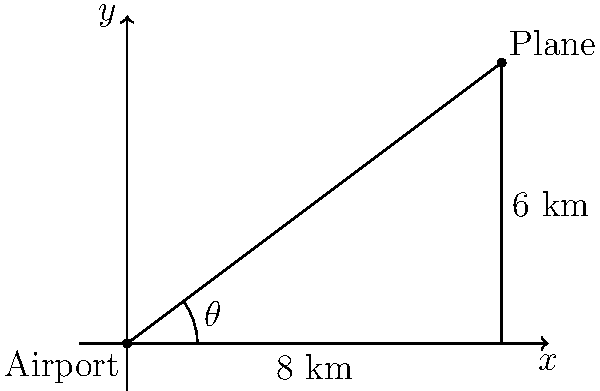An airport's radar system detects a plane at a distance of 10 km and an angle of elevation of 36.87°. What is the plane's altitude and its horizontal distance from the airport? How can this information be used to optimize flight paths and reduce fuel consumption? Let's approach this step-by-step:

1) We can use trigonometric functions to solve this problem. Let's define our variables:
   - $\theta$ = angle of elevation = 36.87°
   - $h$ = hypotenuse (radar distance) = 10 km
   - $y$ = altitude (opposite side)
   - $x$ = horizontal distance (adjacent side)

2) To find the altitude (y):
   $$\sin(\theta) = \frac{\text{opposite}}{\text{hypotenuse}} = \frac{y}{h}$$
   $$y = h \cdot \sin(\theta) = 10 \cdot \sin(36.87°) \approx 6 \text{ km}$$

3) To find the horizontal distance (x):
   $$\cos(\theta) = \frac{\text{adjacent}}{\text{hypotenuse}} = \frac{x}{h}$$
   $$x = h \cdot \cos(\theta) = 10 \cdot \cos(36.87°) \approx 8 \text{ km}$$

4) We can verify our results using the Pythagorean theorem:
   $$x^2 + y^2 = h^2$$
   $$8^2 + 6^2 = 10^2$$
   $$64 + 36 = 100$$

5) This information can be used to optimize flight paths and reduce fuel consumption by:
   - Calculating the most efficient ascent and descent angles
   - Determining optimal cruising altitudes
   - Planning more direct routes while considering obstacles and restricted airspace
   - Adjusting flight paths in real-time based on current position and destination

By accurately knowing the plane's position, airlines can make data-driven decisions to minimize fuel usage, reduce flight times, and lower operational costs.
Answer: Altitude: 6 km, Horizontal distance: 8 km 